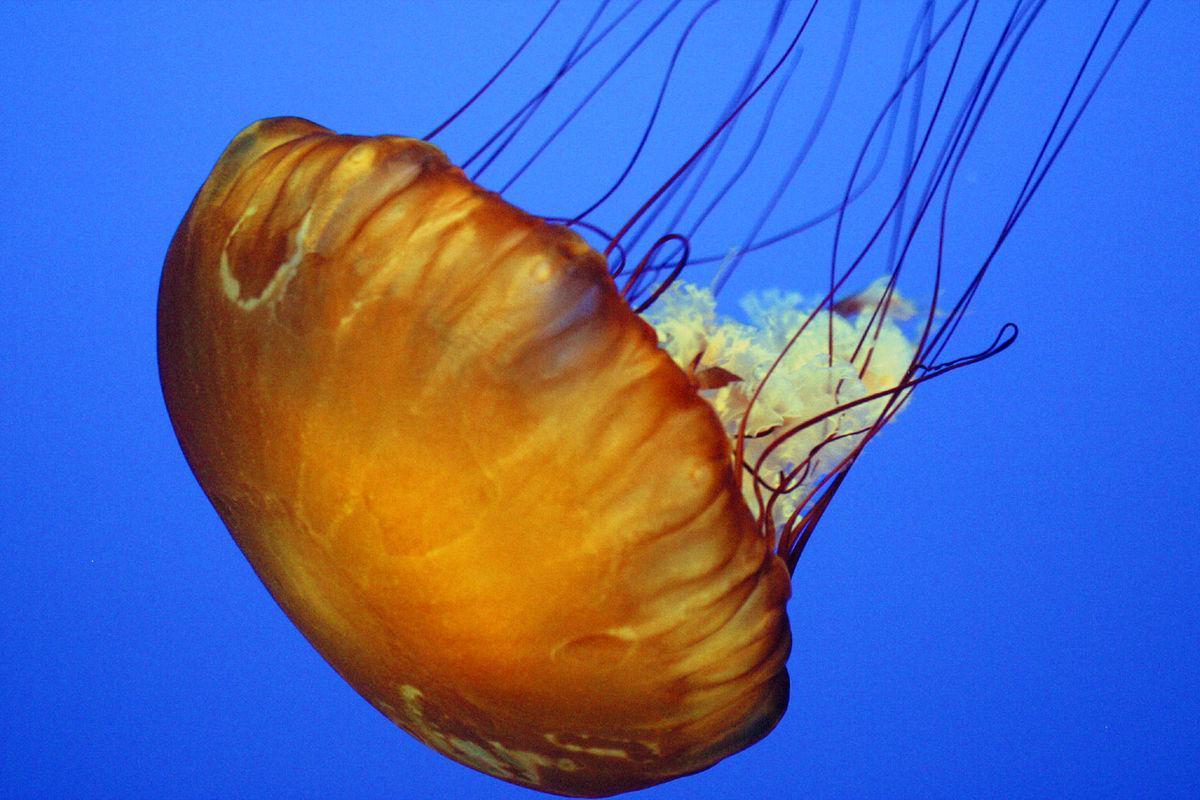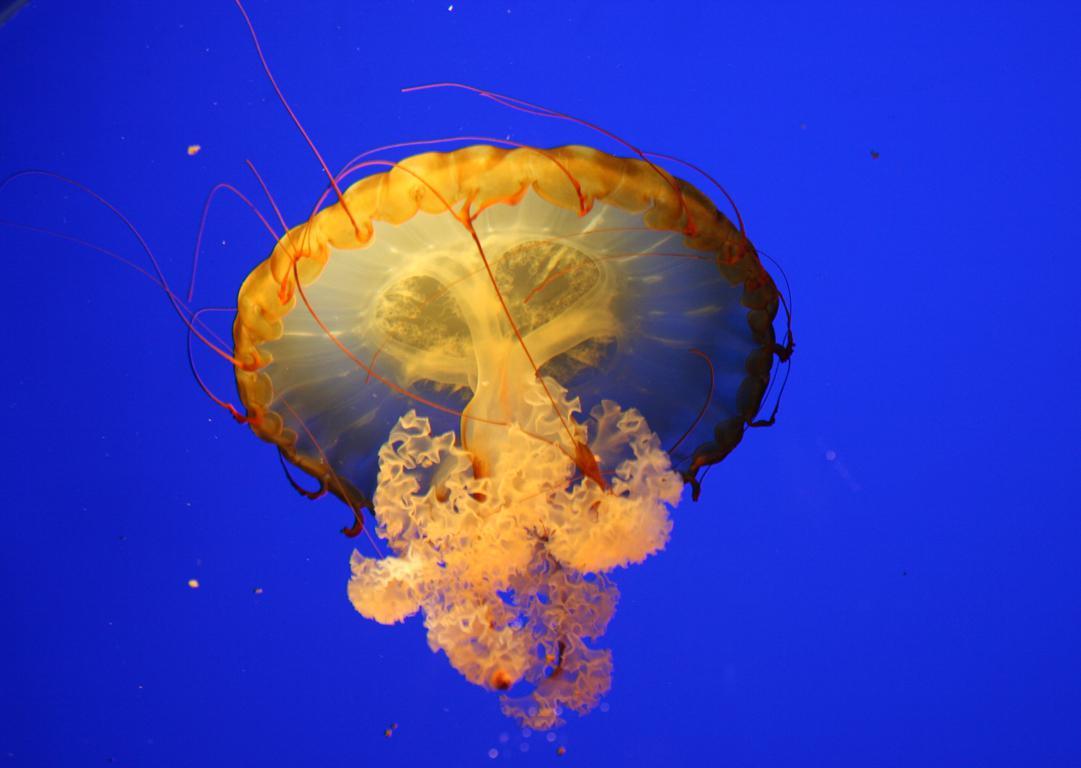The first image is the image on the left, the second image is the image on the right. For the images displayed, is the sentence "There are a total of three jellyfish." factually correct? Answer yes or no. No. 